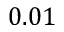Convert formula to latex. <formula><loc_0><loc_0><loc_500><loc_500>0 . 0 1</formula> 